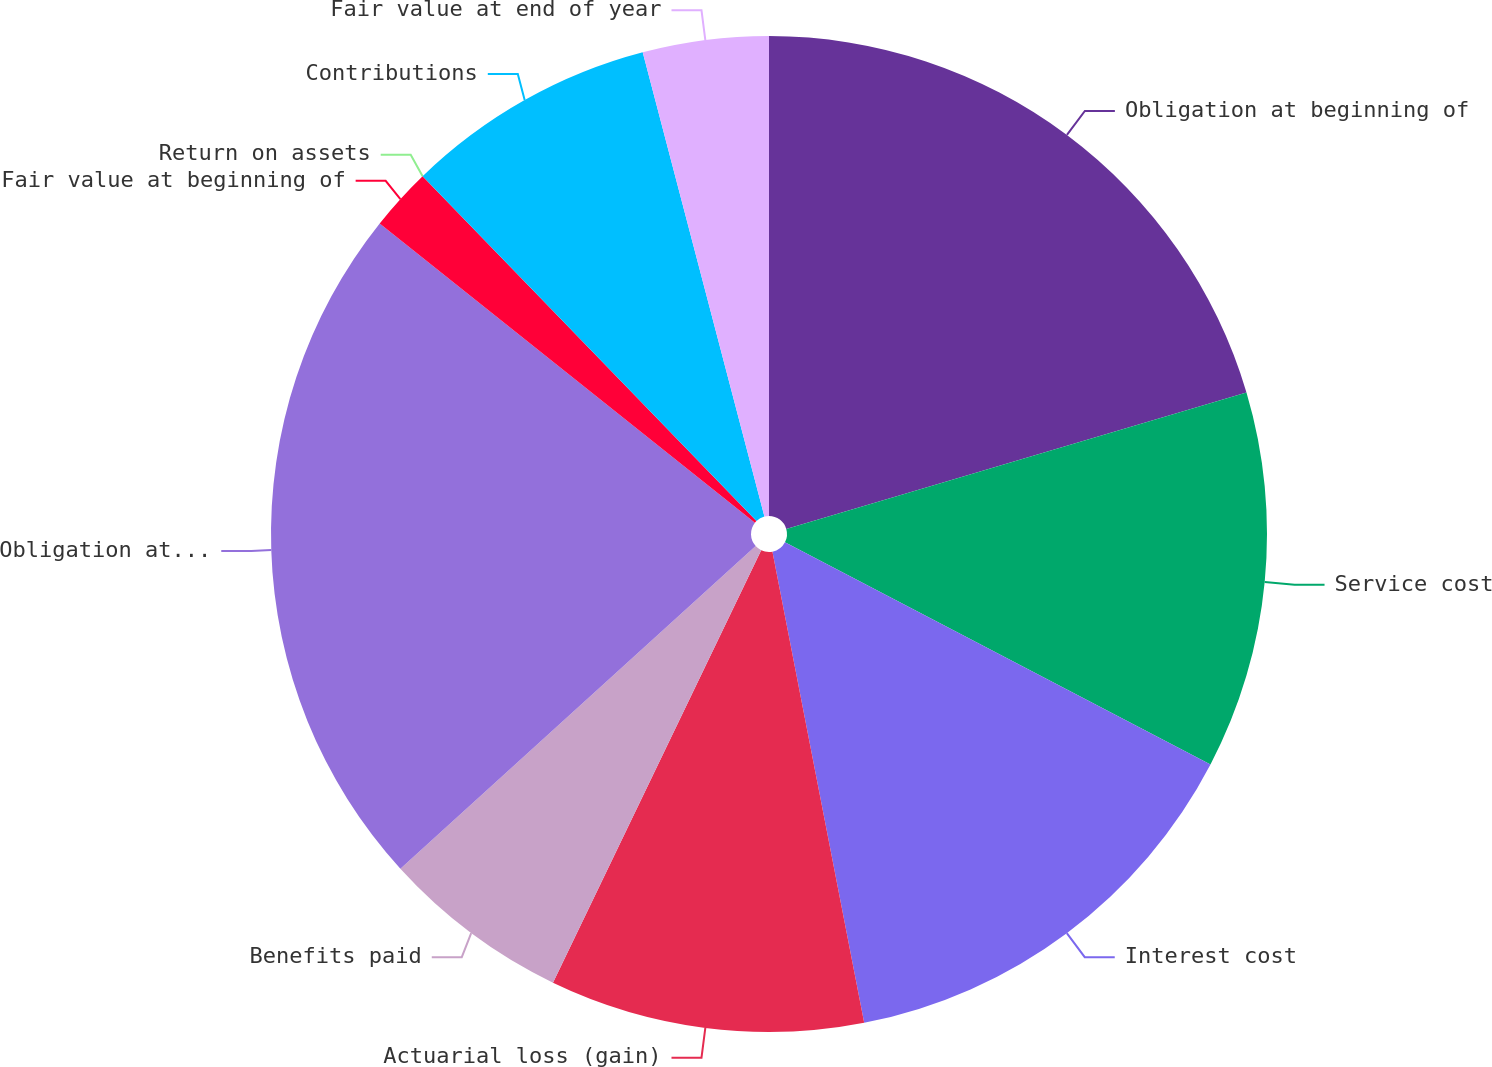Convert chart to OTSL. <chart><loc_0><loc_0><loc_500><loc_500><pie_chart><fcel>Obligation at beginning of<fcel>Service cost<fcel>Interest cost<fcel>Actuarial loss (gain)<fcel>Benefits paid<fcel>Obligation at end of year<fcel>Fair value at beginning of<fcel>Return on assets<fcel>Contributions<fcel>Fair value at end of year<nl><fcel>20.41%<fcel>12.24%<fcel>14.28%<fcel>10.2%<fcel>6.12%<fcel>22.45%<fcel>2.04%<fcel>0.0%<fcel>8.16%<fcel>4.08%<nl></chart> 